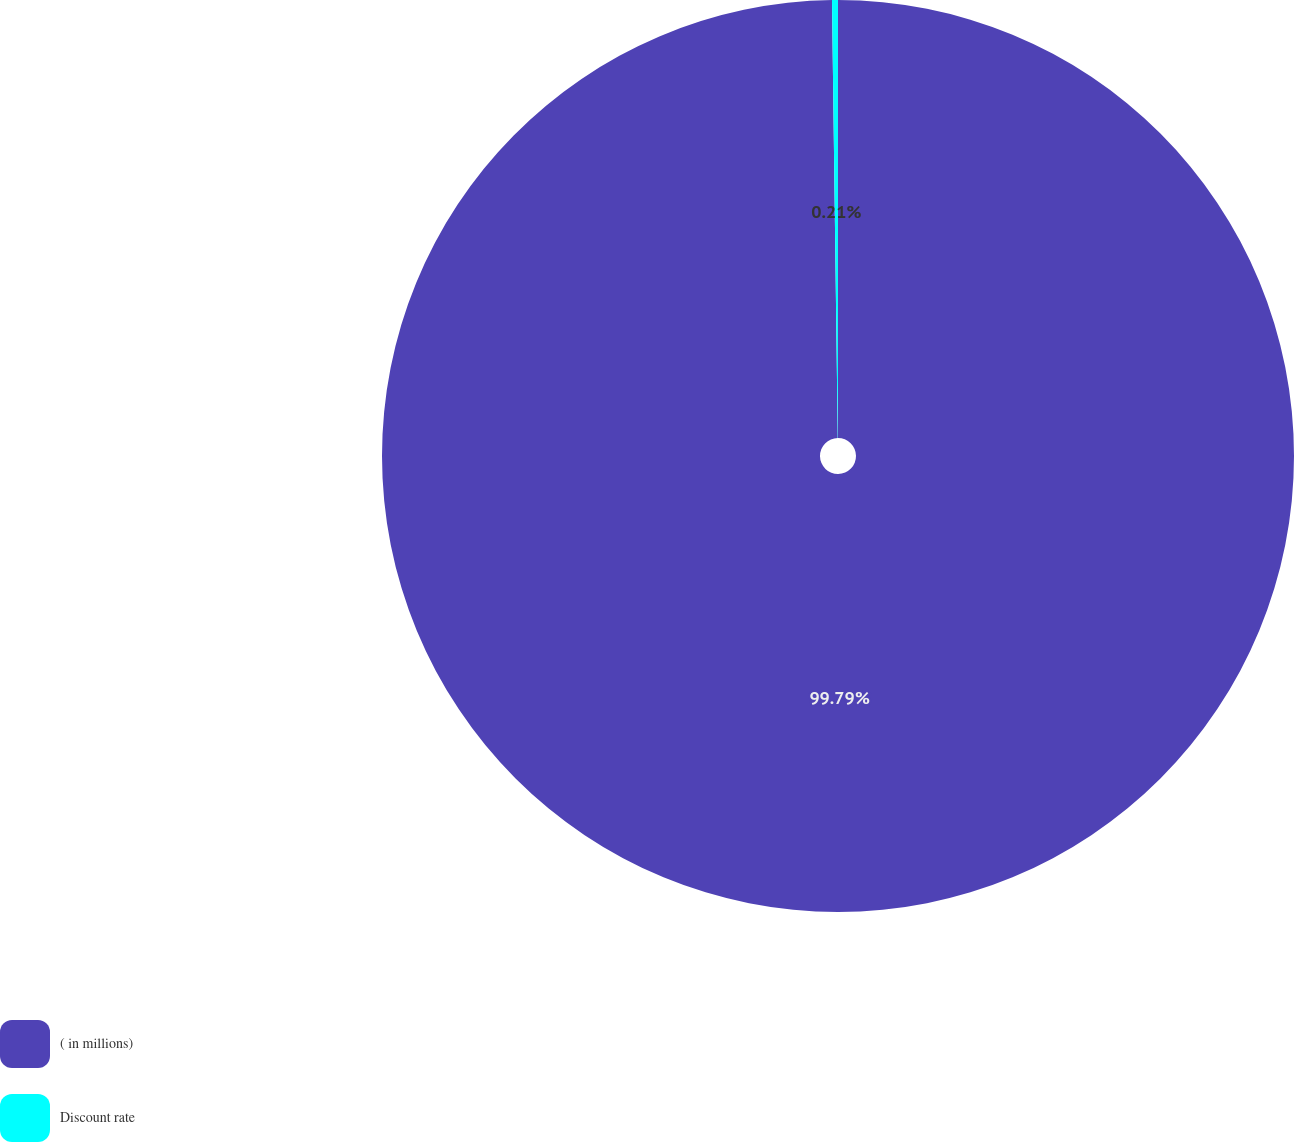Convert chart. <chart><loc_0><loc_0><loc_500><loc_500><pie_chart><fcel>( in millions)<fcel>Discount rate<nl><fcel>99.79%<fcel>0.21%<nl></chart> 